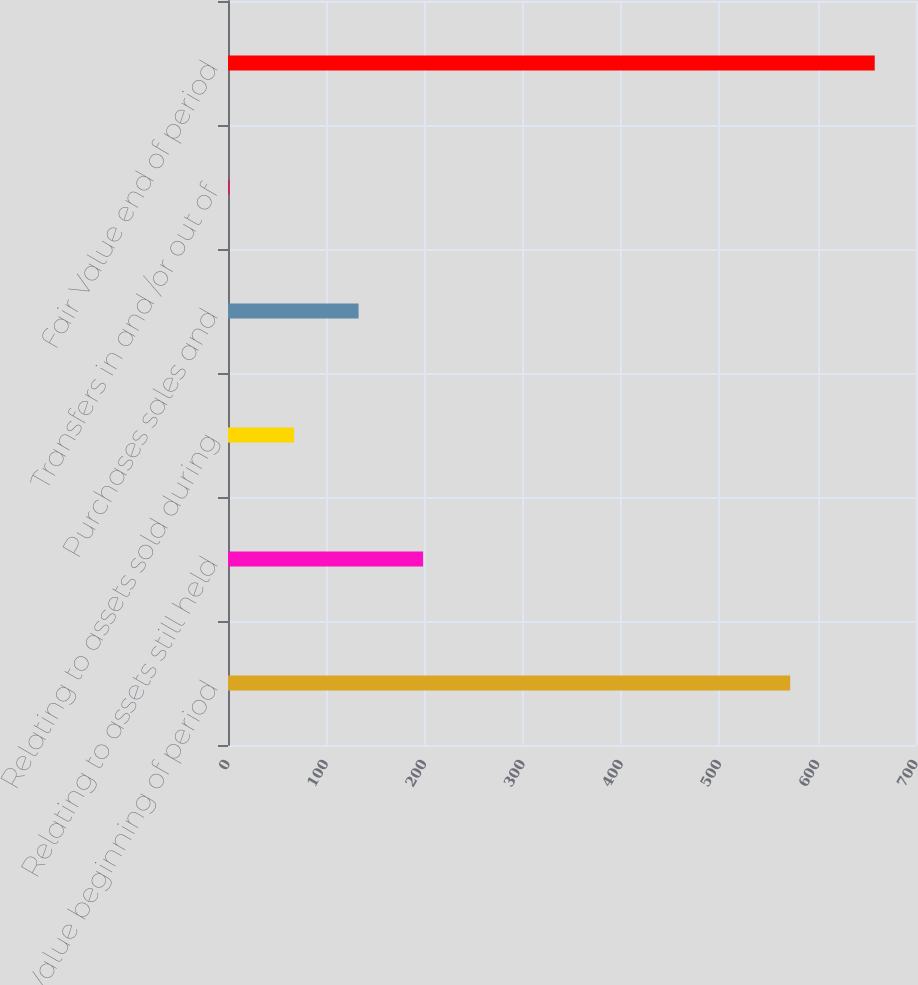Convert chart. <chart><loc_0><loc_0><loc_500><loc_500><bar_chart><fcel>Fair Value beginning of period<fcel>Relating to assets still held<fcel>Relating to assets sold during<fcel>Purchases sales and<fcel>Transfers in and /or out of<fcel>Fair Value end of period<nl><fcel>572<fcel>198.5<fcel>67.2<fcel>132.85<fcel>1.55<fcel>658<nl></chart> 